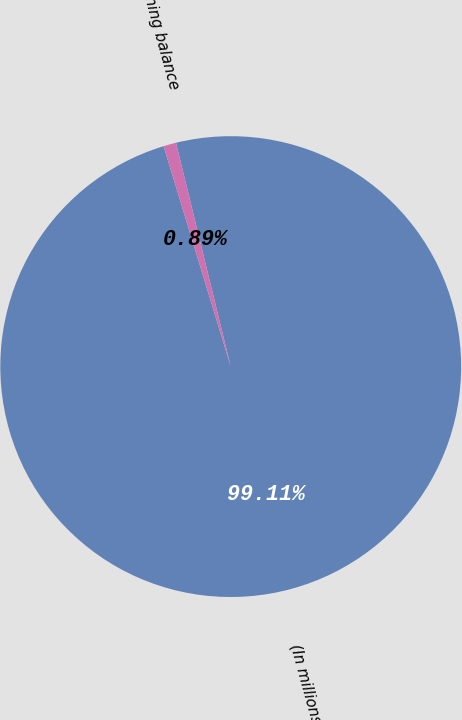Convert chart to OTSL. <chart><loc_0><loc_0><loc_500><loc_500><pie_chart><fcel>(In millions)<fcel>Beginning balance<nl><fcel>99.11%<fcel>0.89%<nl></chart> 